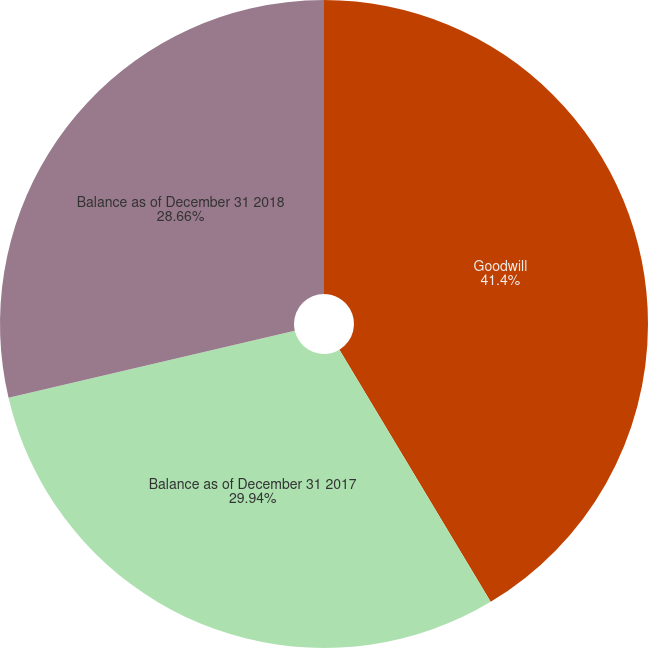Convert chart to OTSL. <chart><loc_0><loc_0><loc_500><loc_500><pie_chart><fcel>Goodwill<fcel>Balance as of December 31 2017<fcel>Balance as of December 31 2018<nl><fcel>41.4%<fcel>29.94%<fcel>28.66%<nl></chart> 